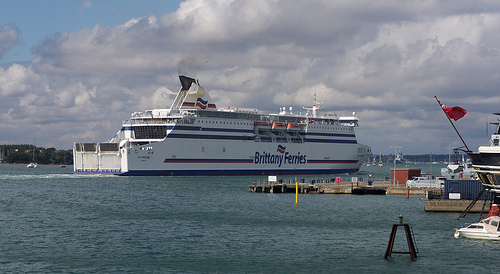Please provide a short description for this region: [0.76, 0.64, 0.84, 0.76]. An old, rusted buoy situated on the pier. 